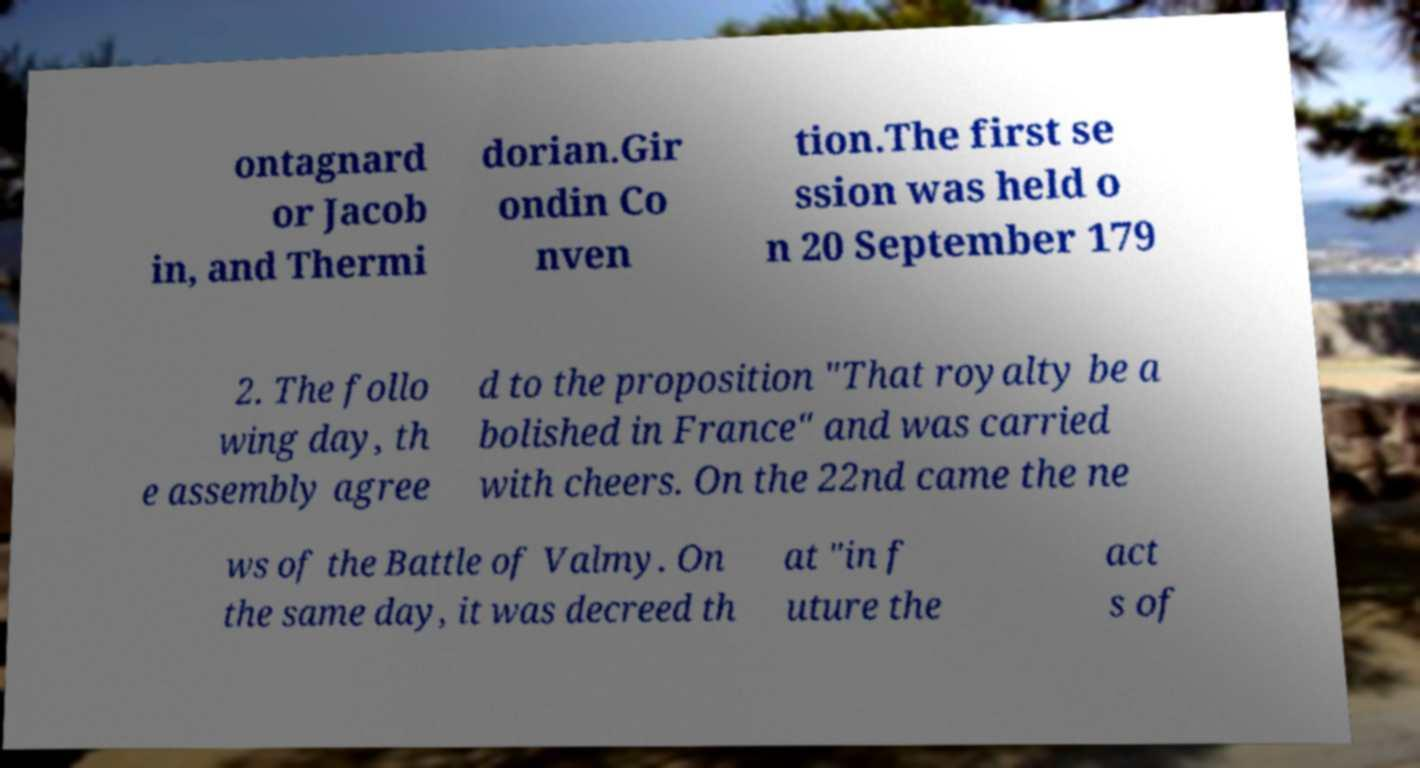Please read and relay the text visible in this image. What does it say? ontagnard or Jacob in, and Thermi dorian.Gir ondin Co nven tion.The first se ssion was held o n 20 September 179 2. The follo wing day, th e assembly agree d to the proposition "That royalty be a bolished in France" and was carried with cheers. On the 22nd came the ne ws of the Battle of Valmy. On the same day, it was decreed th at "in f uture the act s of 